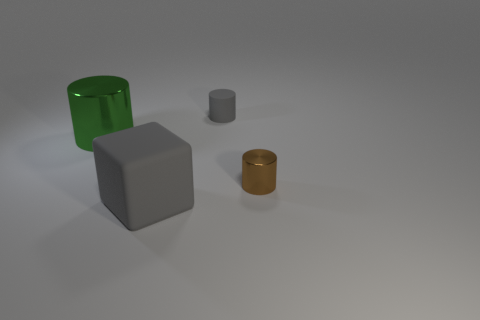There is a rubber object that is the same shape as the brown shiny thing; what is its size?
Your answer should be compact. Small. The big rubber object has what color?
Ensure brevity in your answer.  Gray. Are there any other things that are the same shape as the large gray matte object?
Provide a short and direct response. No. Does the large thing that is to the right of the green thing have the same color as the tiny matte object?
Offer a terse response. Yes. How many other things are the same color as the tiny metal thing?
Give a very brief answer. 0. There is a gray rubber object that is the same size as the green shiny thing; what is its shape?
Your response must be concise. Cube. What size is the metal cylinder right of the tiny gray cylinder?
Offer a terse response. Small. Do the big object that is behind the large gray matte block and the shiny cylinder that is right of the big gray matte object have the same color?
Your answer should be very brief. No. What material is the small cylinder that is in front of the large green shiny cylinder that is on the left side of the shiny cylinder that is right of the gray cube made of?
Offer a terse response. Metal. Is there a brown object of the same size as the gray cylinder?
Offer a very short reply. Yes. 